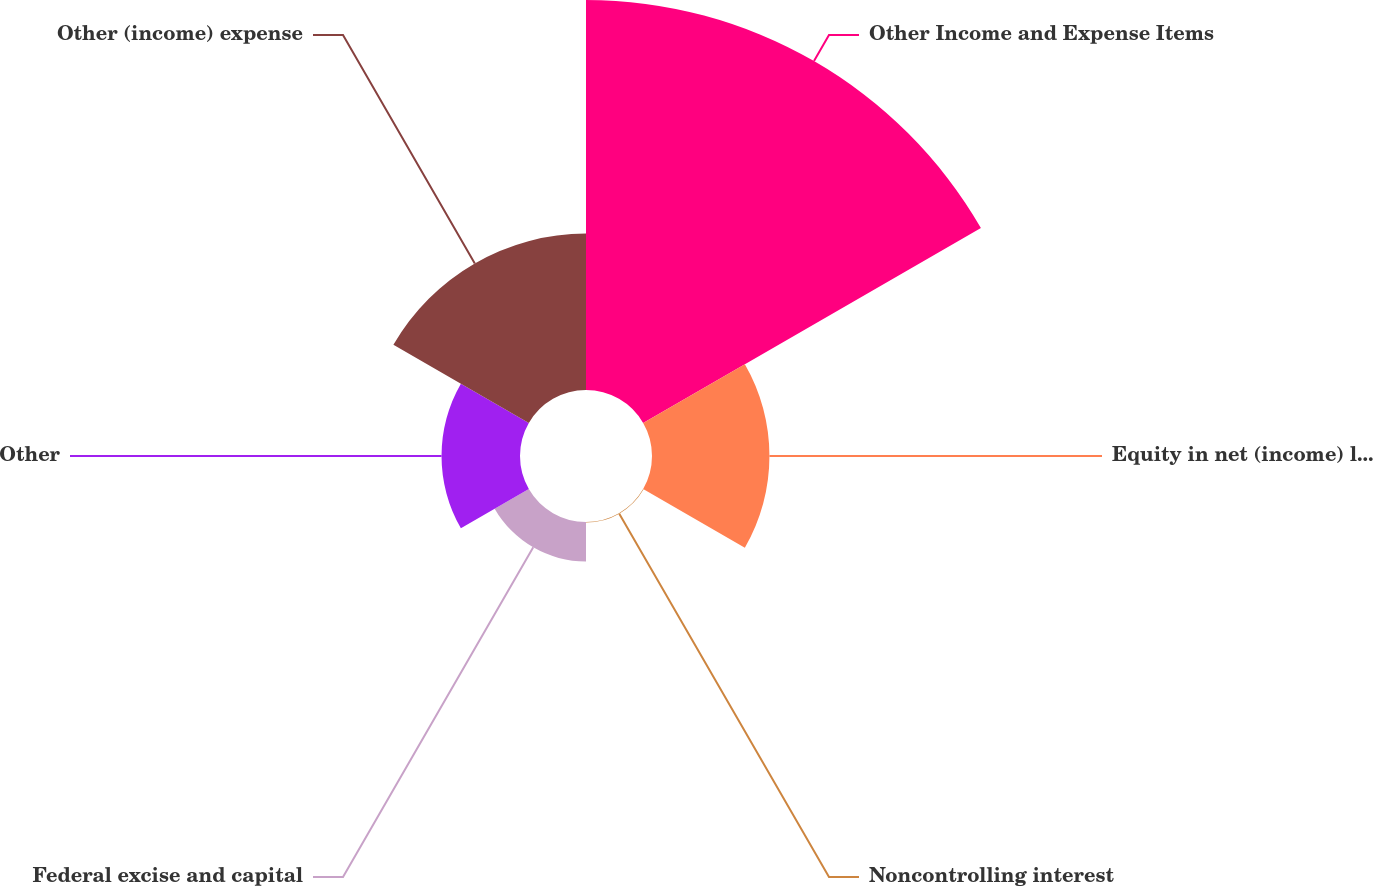<chart> <loc_0><loc_0><loc_500><loc_500><pie_chart><fcel>Other Income and Expense Items<fcel>Equity in net (income) loss of<fcel>Noncontrolling interest<fcel>Federal excise and capital<fcel>Other<fcel>Other (income) expense<nl><fcel>49.85%<fcel>15.01%<fcel>0.07%<fcel>5.05%<fcel>10.03%<fcel>19.99%<nl></chart> 